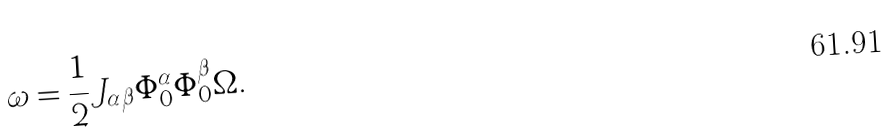Convert formula to latex. <formula><loc_0><loc_0><loc_500><loc_500>\omega = \frac { 1 } { 2 } J _ { \alpha \beta } \Phi ^ { \alpha } _ { 0 } \Phi ^ { \beta } _ { 0 } \Omega .</formula> 